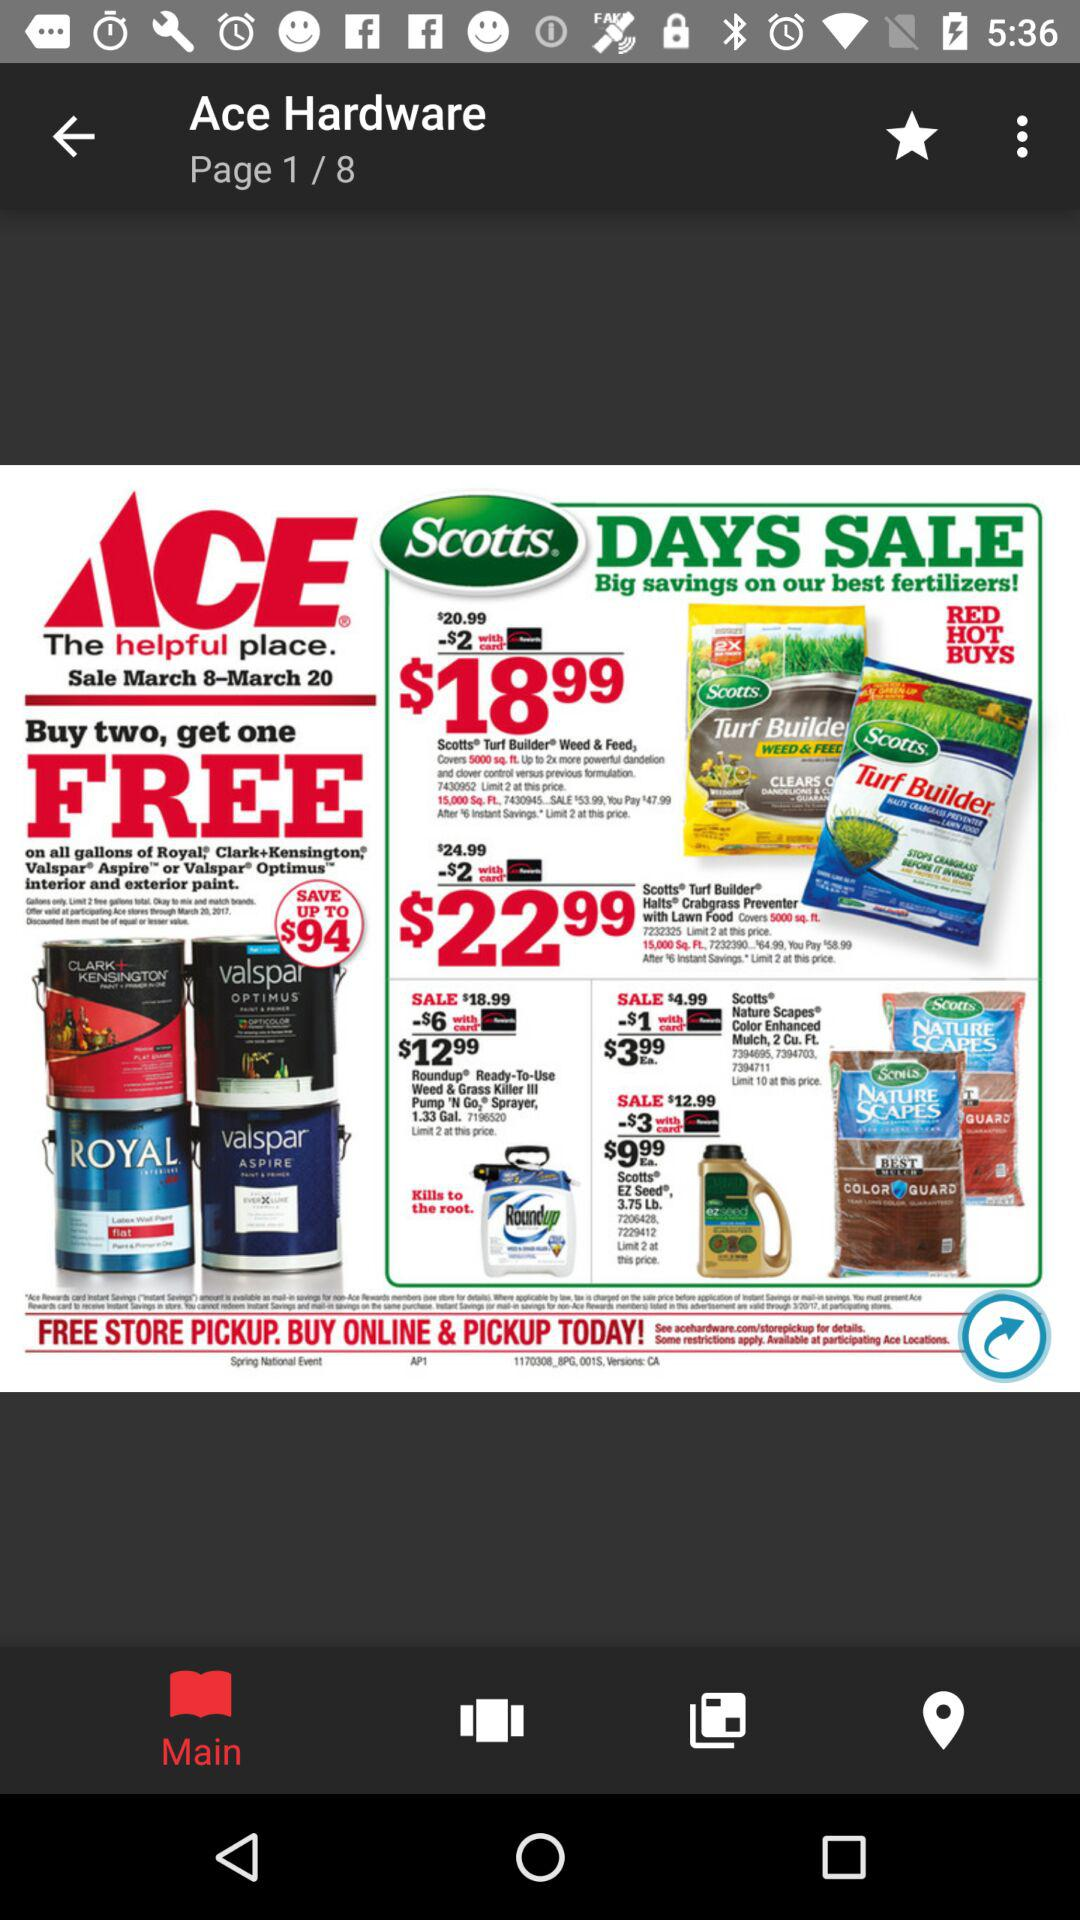Which page am I on? You are on page 1. 